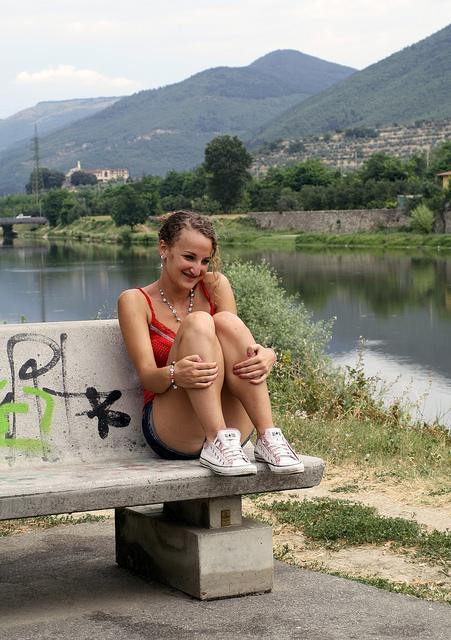How does this person feel about the photographer? likes 